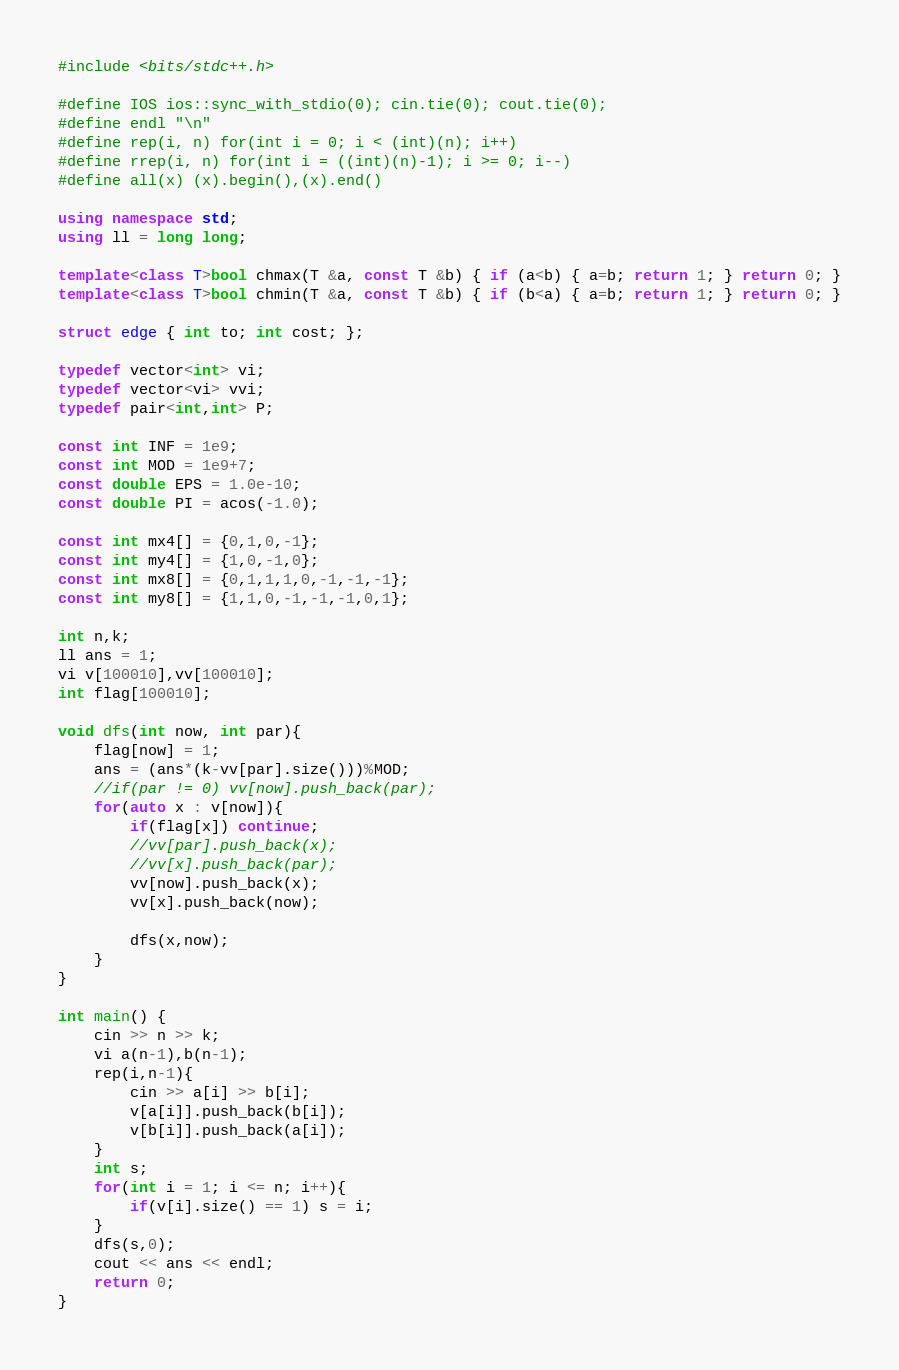Convert code to text. <code><loc_0><loc_0><loc_500><loc_500><_C++_>#include <bits/stdc++.h>
 
#define IOS ios::sync_with_stdio(0); cin.tie(0); cout.tie(0);
#define endl "\n"
#define rep(i, n) for(int i = 0; i < (int)(n); i++)
#define rrep(i, n) for(int i = ((int)(n)-1); i >= 0; i--)
#define all(x) (x).begin(),(x).end()
 
using namespace std;
using ll = long long;
 
template<class T>bool chmax(T &a, const T &b) { if (a<b) { a=b; return 1; } return 0; }
template<class T>bool chmin(T &a, const T &b) { if (b<a) { a=b; return 1; } return 0; }

struct edge { int to; int cost; };
 
typedef vector<int> vi;
typedef vector<vi> vvi;
typedef pair<int,int> P;
 
const int INF = 1e9;
const int MOD = 1e9+7;
const double EPS = 1.0e-10;
const double PI = acos(-1.0);
 
const int mx4[] = {0,1,0,-1};
const int my4[] = {1,0,-1,0};
const int mx8[] = {0,1,1,1,0,-1,-1,-1};
const int my8[] = {1,1,0,-1,-1,-1,0,1};

int n,k;
ll ans = 1;
vi v[100010],vv[100010];
int flag[100010];

void dfs(int now, int par){
	flag[now] = 1;
	ans = (ans*(k-vv[par].size()))%MOD;
	//if(par != 0) vv[now].push_back(par);
	for(auto x : v[now]){
		if(flag[x]) continue;
		//vv[par].push_back(x);
		//vv[x].push_back(par);
		vv[now].push_back(x);
		vv[x].push_back(now);
		
		dfs(x,now);
	}
}

int main() {
	cin >> n >> k;
	vi a(n-1),b(n-1);
	rep(i,n-1){
		cin >> a[i] >> b[i];
		v[a[i]].push_back(b[i]);
		v[b[i]].push_back(a[i]);
	}
	int s;
	for(int i = 1; i <= n; i++){
		if(v[i].size() == 1) s = i;
	}
	dfs(s,0);
	cout << ans << endl;
	return 0;
}</code> 